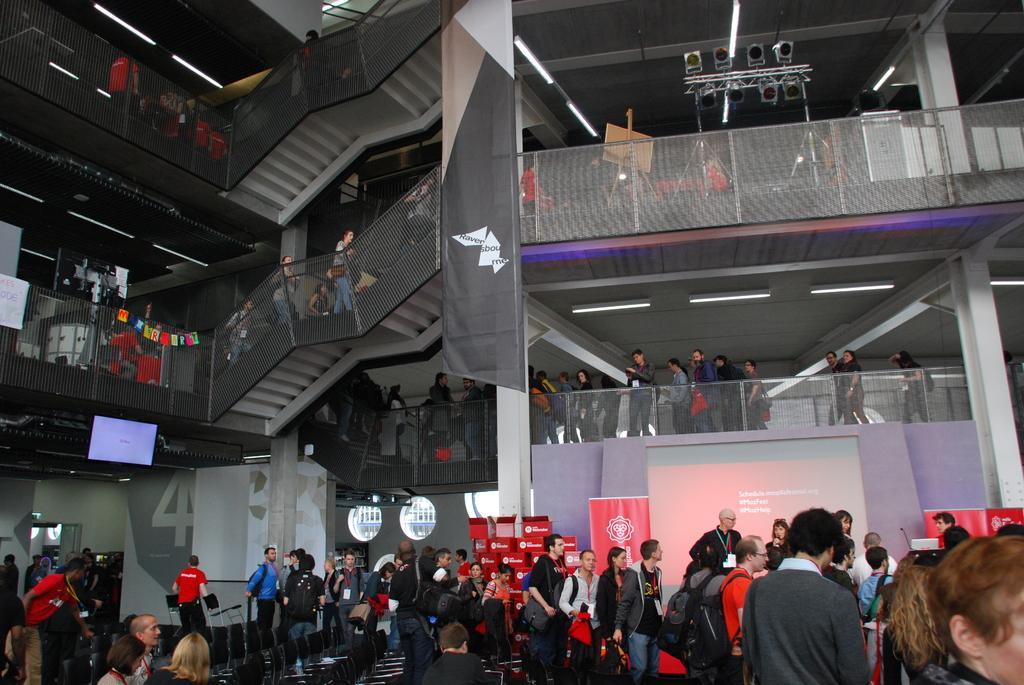Could you give a brief overview of what you see in this image? At the bottom of the image there are people. In the background of the image there are staircase, railing, board, lights, pillars. There is a screen, banners with some text. 